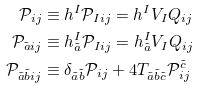Convert formula to latex. <formula><loc_0><loc_0><loc_500><loc_500>\mathcal { P } _ { i j } & \equiv h ^ { I } \mathcal { P } _ { I i j } = h ^ { I } V _ { I } Q _ { i j } \\ \mathcal { P } _ { \tilde { a } i j } & \equiv h ^ { I } _ { \tilde { a } } \mathcal { P } _ { I i j } = h ^ { I } _ { \tilde { a } } V _ { I } Q _ { i j } \\ \mathcal { P } _ { \tilde { a } \tilde { b } i j } & \equiv \delta _ { \tilde { a } \tilde { b } } \mathcal { P } _ { i j } + 4 T _ { \tilde { a } \tilde { b } \tilde { c } } \mathcal { P } ^ { \tilde { c } } _ { i j }</formula> 